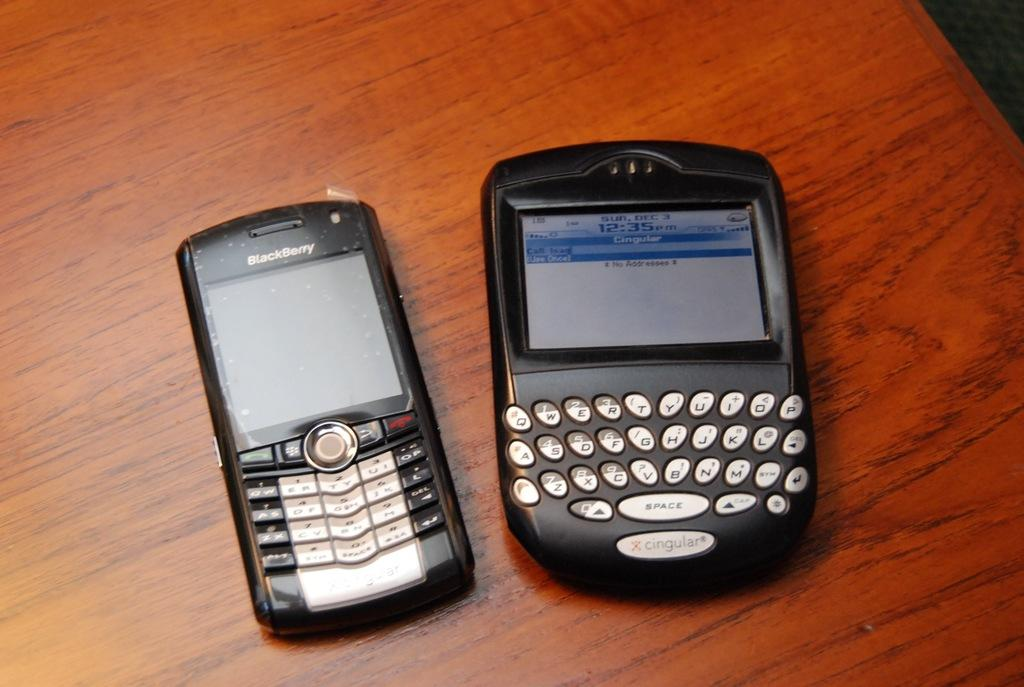How many mobile phones are visible in the image? There are two mobile phones in the image. Where are the mobile phones located? The mobile phones are on a table. Can you describe the lighting in the image? The top right corner of the image appears to be dark. What type of joke is the fowl telling in the image? There is no fowl or joke present in the image. How does the mother interact with the mobile phones in the image? There is no mother present in the image. 